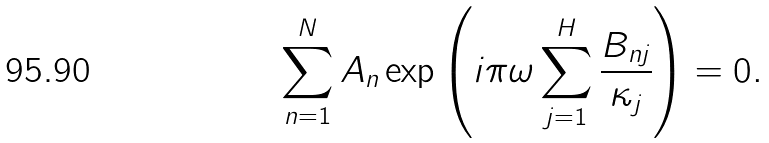<formula> <loc_0><loc_0><loc_500><loc_500>\sum _ { n = 1 } ^ { N } { A _ { n } \exp \left ( i \pi \omega \sum _ { j = 1 } ^ { H } \frac { B _ { n j } } { \kappa _ { j } } \right ) } = 0 .</formula> 